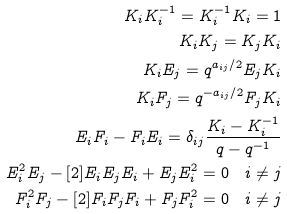Convert formula to latex. <formula><loc_0><loc_0><loc_500><loc_500>K _ { i } K _ { i } ^ { - 1 } = K _ { i } ^ { - 1 } K _ { i } = 1 \\ K _ { i } K _ { j } = K _ { j } K _ { i } \\ K _ { i } E _ { j } = q ^ { a _ { i j } / 2 } E _ { j } K _ { i } \\ K _ { i } F _ { j } = q ^ { - a _ { i j } / 2 } F _ { j } K _ { i } \\ E _ { i } F _ { i } - F _ { i } E _ { i } = \delta _ { i j } \frac { K _ { i } - K _ { i } ^ { - 1 } } { q - q ^ { - 1 } } \\ E _ { i } ^ { 2 } E _ { j } - [ 2 ] E _ { i } E _ { j } E _ { i } + E _ { j } E _ { i } ^ { 2 } = 0 \quad i \ne j \\ F _ { i } ^ { 2 } F _ { j } - [ 2 ] F _ { i } F _ { j } F _ { i } + F _ { j } F _ { i } ^ { 2 } = 0 \quad i \ne j</formula> 